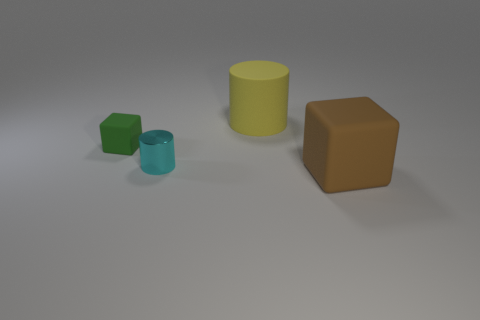Add 3 small green spheres. How many objects exist? 7 Subtract 1 cylinders. How many cylinders are left? 1 Add 2 green rubber things. How many green rubber things are left? 3 Add 2 small cubes. How many small cubes exist? 3 Subtract 1 green cubes. How many objects are left? 3 Subtract all red blocks. Subtract all purple cylinders. How many blocks are left? 2 Subtract all purple spheres. How many purple cylinders are left? 0 Subtract all big blocks. Subtract all green rubber things. How many objects are left? 2 